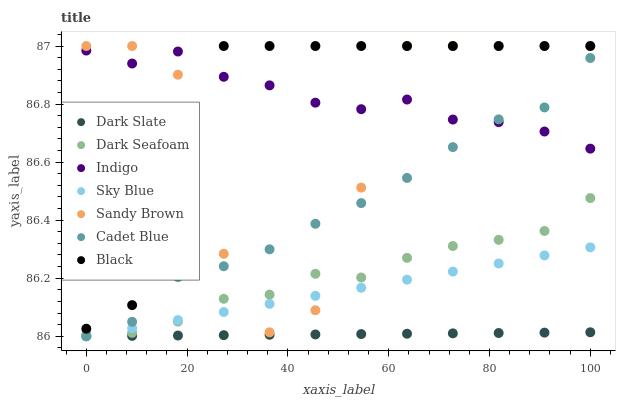Does Dark Slate have the minimum area under the curve?
Answer yes or no. Yes. Does Black have the maximum area under the curve?
Answer yes or no. Yes. Does Indigo have the minimum area under the curve?
Answer yes or no. No. Does Indigo have the maximum area under the curve?
Answer yes or no. No. Is Sky Blue the smoothest?
Answer yes or no. Yes. Is Sandy Brown the roughest?
Answer yes or no. Yes. Is Indigo the smoothest?
Answer yes or no. No. Is Indigo the roughest?
Answer yes or no. No. Does Cadet Blue have the lowest value?
Answer yes or no. Yes. Does Indigo have the lowest value?
Answer yes or no. No. Does Sandy Brown have the highest value?
Answer yes or no. Yes. Does Indigo have the highest value?
Answer yes or no. No. Is Sky Blue less than Black?
Answer yes or no. Yes. Is Indigo greater than Dark Slate?
Answer yes or no. Yes. Does Sky Blue intersect Dark Seafoam?
Answer yes or no. Yes. Is Sky Blue less than Dark Seafoam?
Answer yes or no. No. Is Sky Blue greater than Dark Seafoam?
Answer yes or no. No. Does Sky Blue intersect Black?
Answer yes or no. No. 